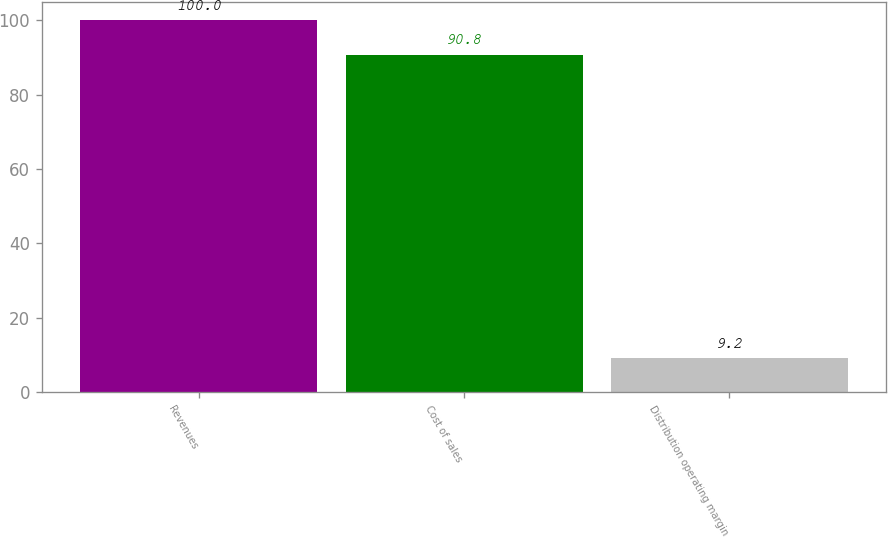<chart> <loc_0><loc_0><loc_500><loc_500><bar_chart><fcel>Revenues<fcel>Cost of sales<fcel>Distribution operating margin<nl><fcel>100<fcel>90.8<fcel>9.2<nl></chart> 